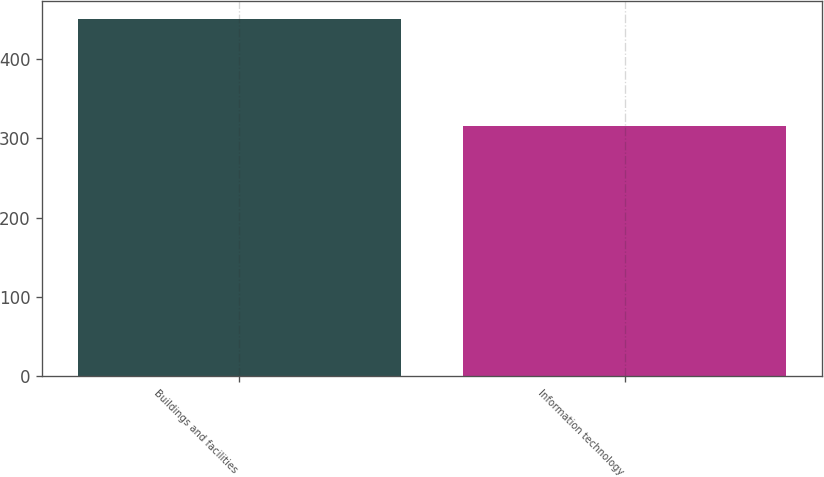Convert chart to OTSL. <chart><loc_0><loc_0><loc_500><loc_500><bar_chart><fcel>Buildings and facilities<fcel>Information technology<nl><fcel>451<fcel>316<nl></chart> 